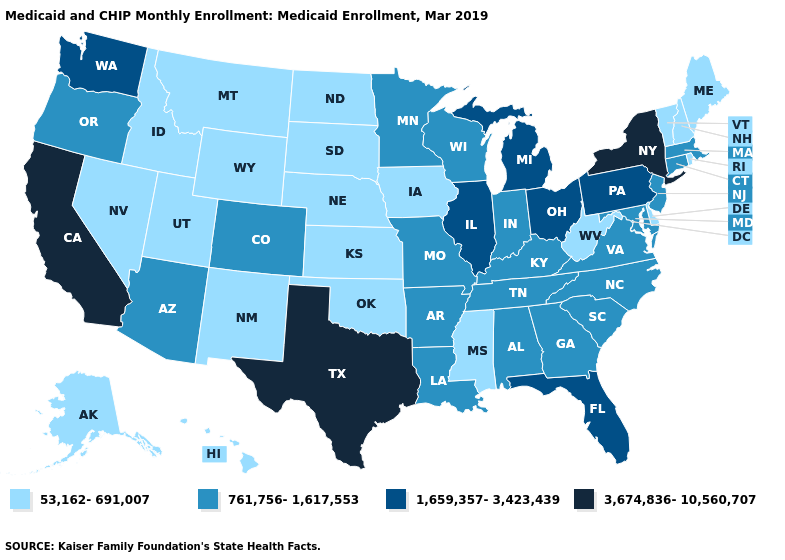What is the highest value in the MidWest ?
Quick response, please. 1,659,357-3,423,439. What is the value of Nebraska?
Write a very short answer. 53,162-691,007. Does South Dakota have the lowest value in the USA?
Give a very brief answer. Yes. Name the states that have a value in the range 3,674,836-10,560,707?
Write a very short answer. California, New York, Texas. What is the highest value in the USA?
Keep it brief. 3,674,836-10,560,707. Name the states that have a value in the range 1,659,357-3,423,439?
Quick response, please. Florida, Illinois, Michigan, Ohio, Pennsylvania, Washington. What is the value of North Carolina?
Write a very short answer. 761,756-1,617,553. What is the highest value in the Northeast ?
Give a very brief answer. 3,674,836-10,560,707. Among the states that border New Hampshire , does Massachusetts have the highest value?
Concise answer only. Yes. Which states have the lowest value in the South?
Short answer required. Delaware, Mississippi, Oklahoma, West Virginia. Does the map have missing data?
Answer briefly. No. What is the lowest value in the MidWest?
Concise answer only. 53,162-691,007. Does the map have missing data?
Quick response, please. No. Does Minnesota have the highest value in the USA?
Write a very short answer. No. Among the states that border Nebraska , does South Dakota have the highest value?
Concise answer only. No. 